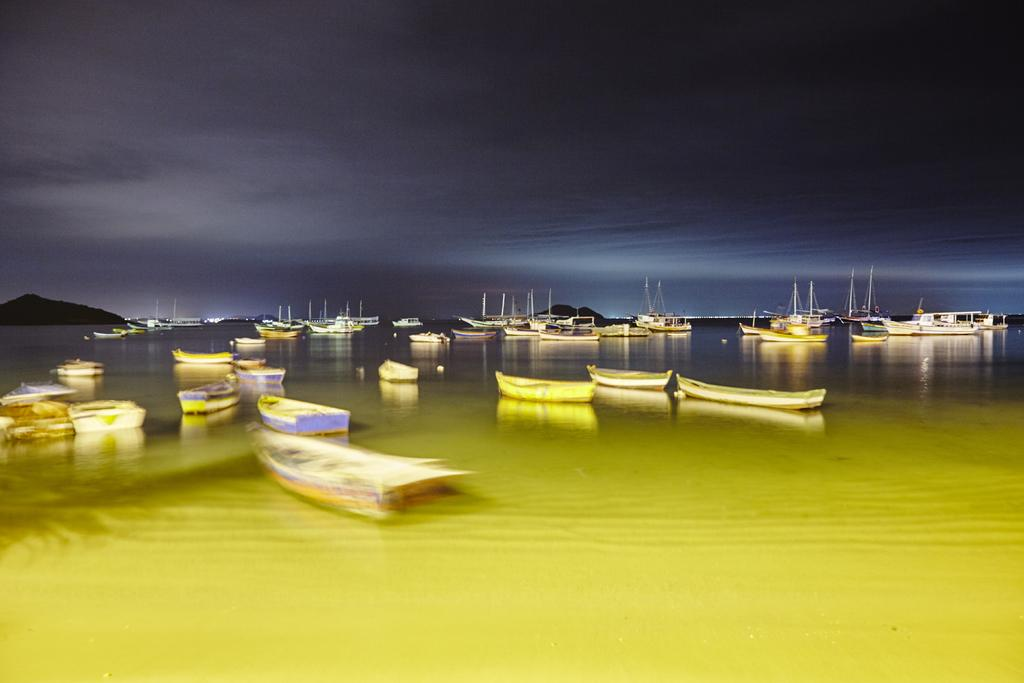What types of watercraft are visible in the image? There are ships and boats in the image. Where are the ships and boats located? The ships and boats are on the water. What can be seen in the background of the image? There are mountains in the background of the image. What is visible in the sky in the image? The sky is visible in the image, and clouds are present. What type of structure can be seen in the image? There is a bridge in the image. What type of hospital can be seen in the image? There is no hospital present in the image; it features ships, boats, mountains, sky, clouds, and a bridge. What type of battle is taking place in the image? There is no battle present in the image; it is a peaceful scene with ships, boats, mountains, sky, clouds, and a bridge. 